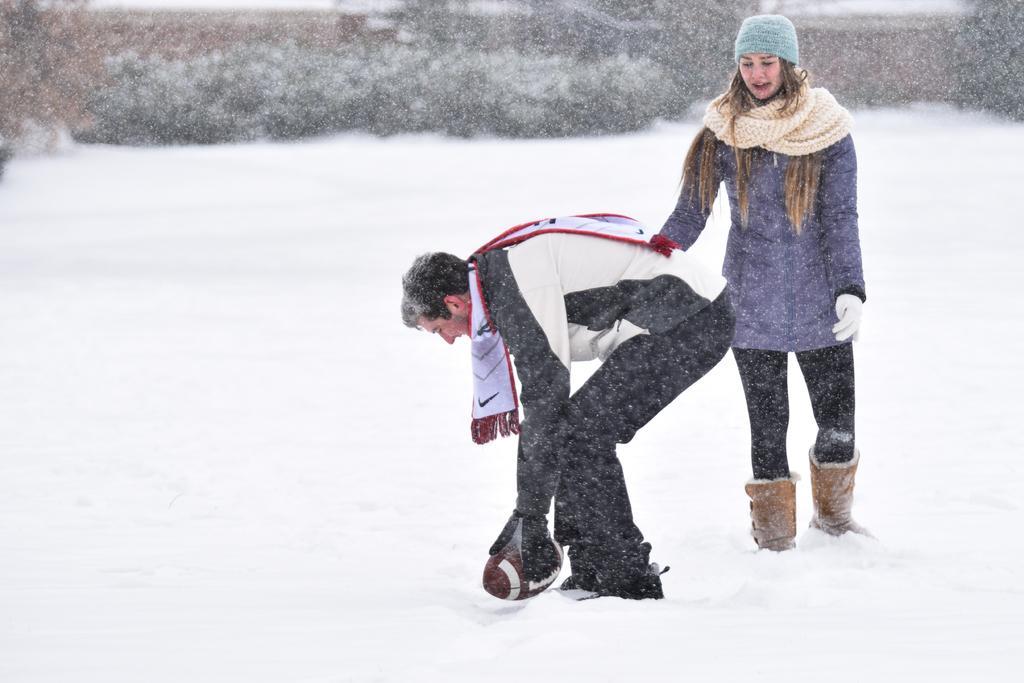Can you describe this image briefly? In the front of the image I can see a man and woman. Man is holding a ball and wore scarf. Land is covered with snow. In the background of the image I can see plants. 